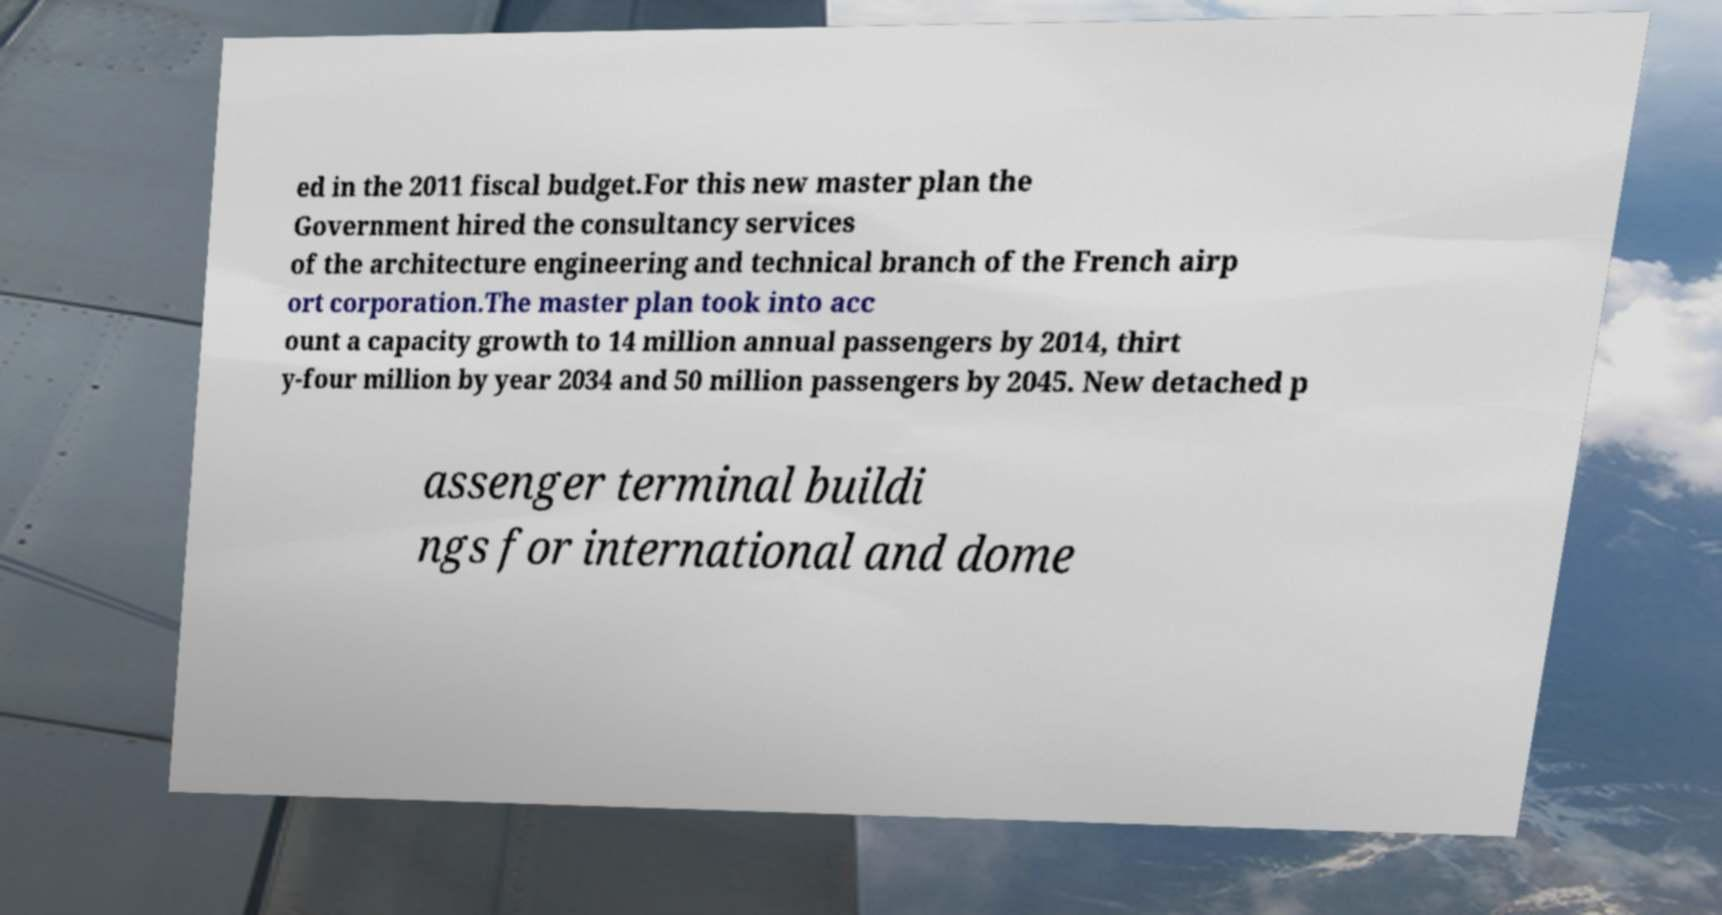Could you extract and type out the text from this image? ed in the 2011 fiscal budget.For this new master plan the Government hired the consultancy services of the architecture engineering and technical branch of the French airp ort corporation.The master plan took into acc ount a capacity growth to 14 million annual passengers by 2014, thirt y-four million by year 2034 and 50 million passengers by 2045. New detached p assenger terminal buildi ngs for international and dome 